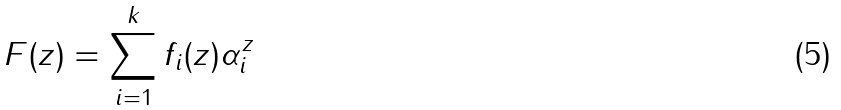Convert formula to latex. <formula><loc_0><loc_0><loc_500><loc_500>F ( z ) = \sum _ { i = 1 } ^ { k } f _ { i } ( z ) \alpha _ { i } ^ { z }</formula> 